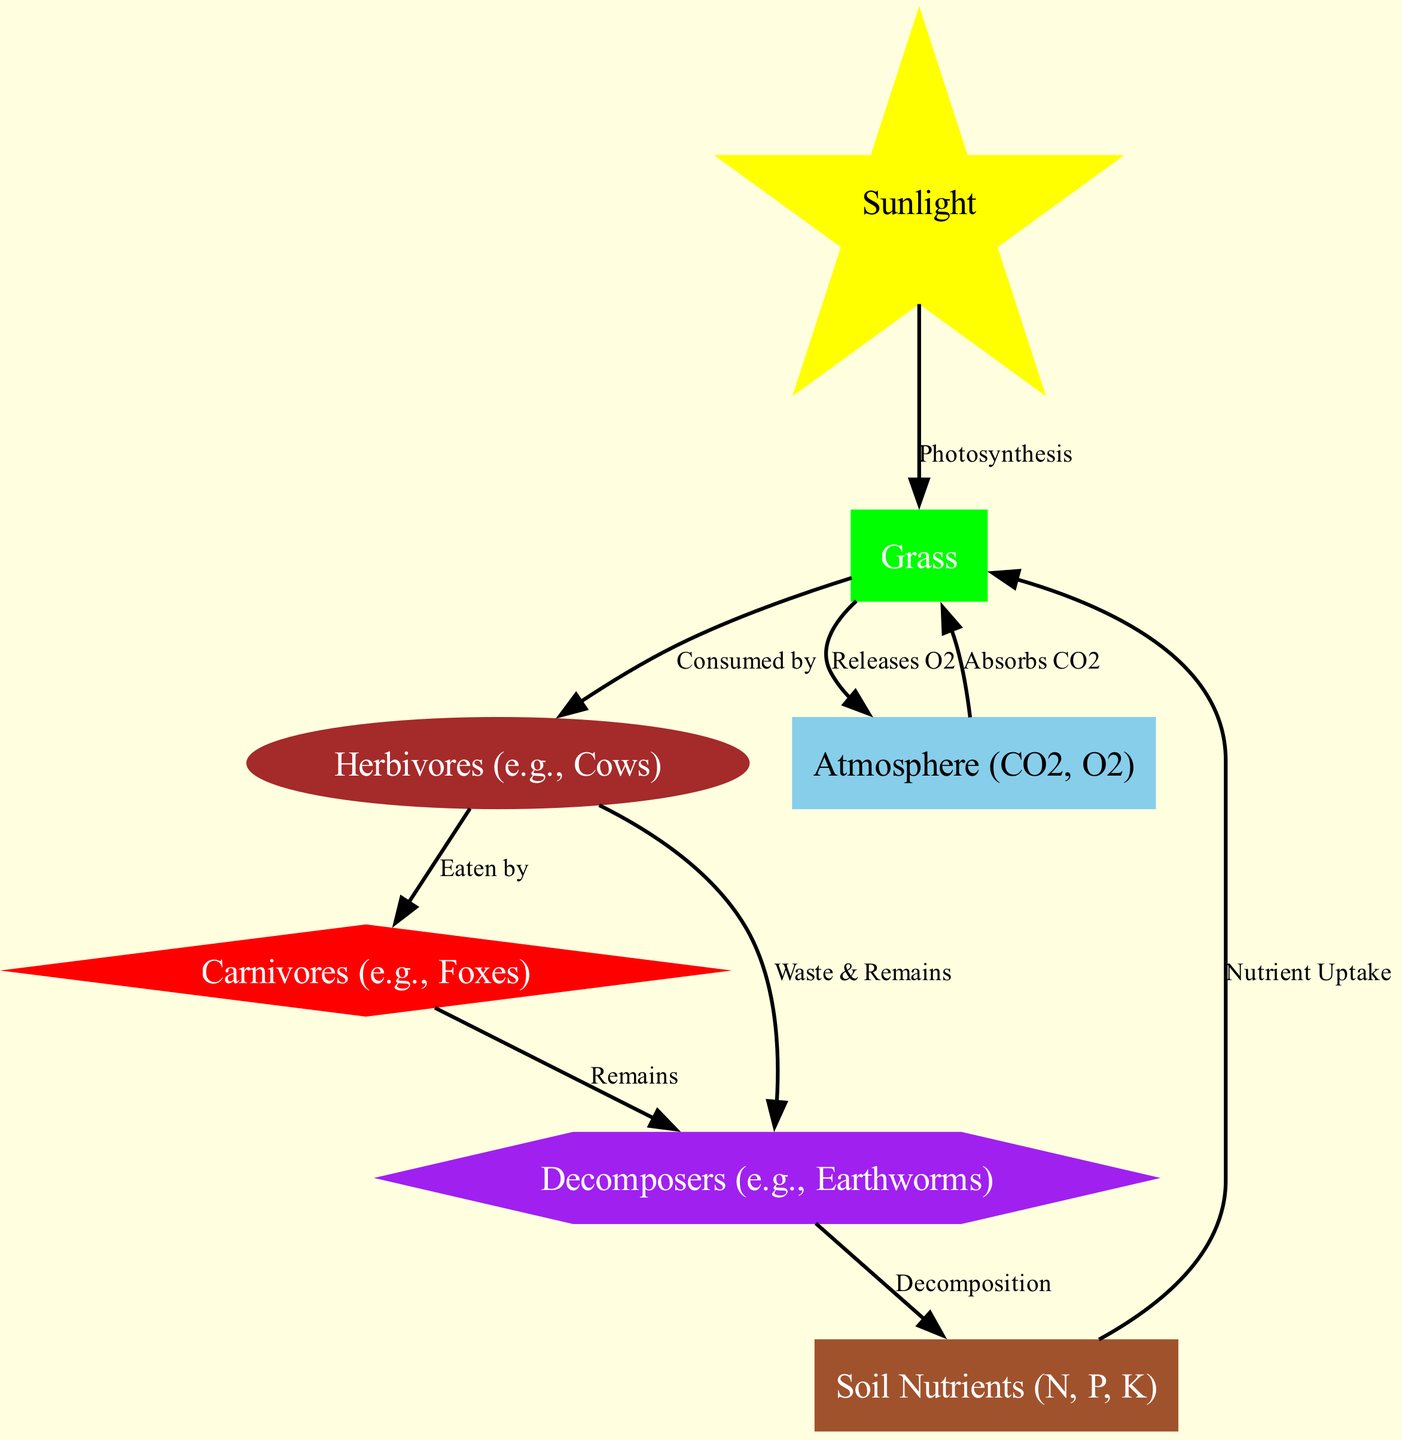What is the first node in the nutrient cycle? The first node is "Sunlight," which initiates the cycle through photosynthesis.
Answer: Sunlight How many nodes are present in the diagram? The diagram includes 7 distinct nodes: Sunlight, Grass, Herbivores, Carnivores, Decomposers, Soil Nutrients, and Atmosphere.
Answer: 7 What process connects Grass to Herbivores? The relationship is defined as "Consumed by" which indicates that Herbivores derive their energy from Grass.
Answer: Consumed by Which node is a source of CO2 and O2 in the ecosystem? The "Atmosphere" node represents both Carbon Dioxide (CO2) and Oxygen (O2) as essential gases for the ecosystem.
Answer: Atmosphere What do Decomposers produce that replenishes Soil Nutrients? Decomposers break down organic material, creating nutrients through the process of decomposition, thus nourishing Soil Nutrients.
Answer: Decomposition How many edges are there in total in the diagram? By counting the directed arrows connecting the nodes, there are 8 edges in total, showing various relationships in the nutrient cycle.
Answer: 8 What do Grass and the Atmosphere exchange in the cycle? Grass absorbs CO2 from the Atmosphere for photosynthesis and releases O2 back into it as a byproduct.
Answer: Absorbs CO2, Releases O2 Who are the primary consumers in the nutrient cycle? The primary consumers represented in the diagram are the "Herbivores," which directly consume Grass.
Answer: Herbivores How do Carnivores obtain their energy according to the diagram? Carnivores obtain their energy by eating Herbivores, which establishes a predator-prey relationship in the food chain.
Answer: Eaten by 